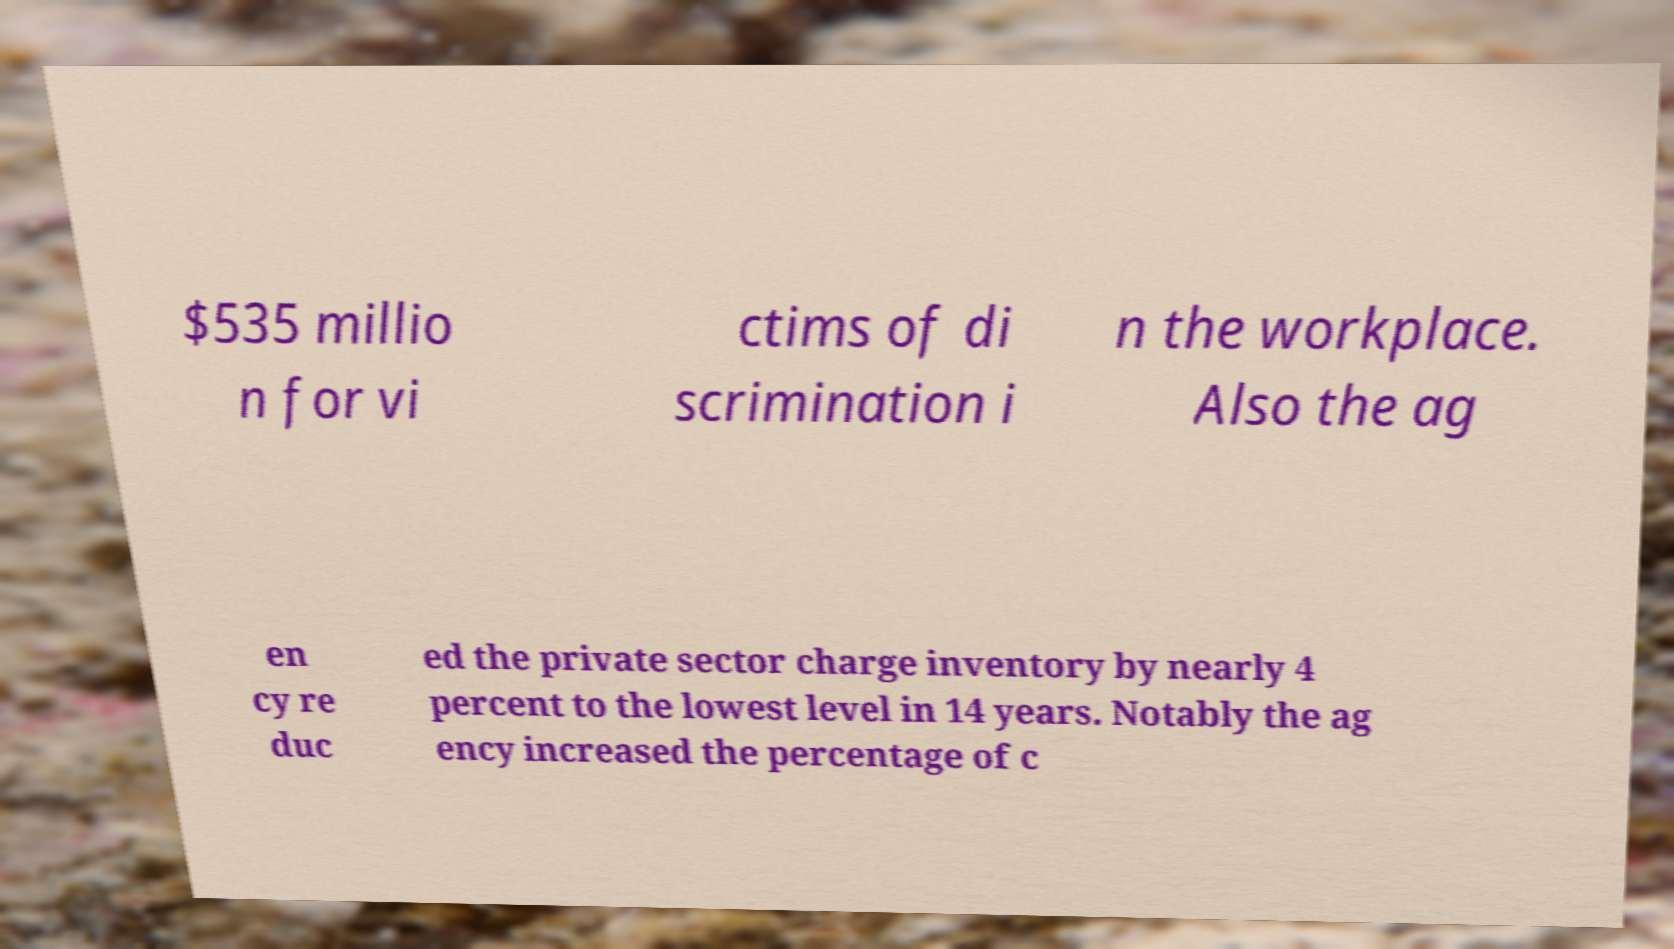Can you accurately transcribe the text from the provided image for me? $535 millio n for vi ctims of di scrimination i n the workplace. Also the ag en cy re duc ed the private sector charge inventory by nearly 4 percent to the lowest level in 14 years. Notably the ag ency increased the percentage of c 